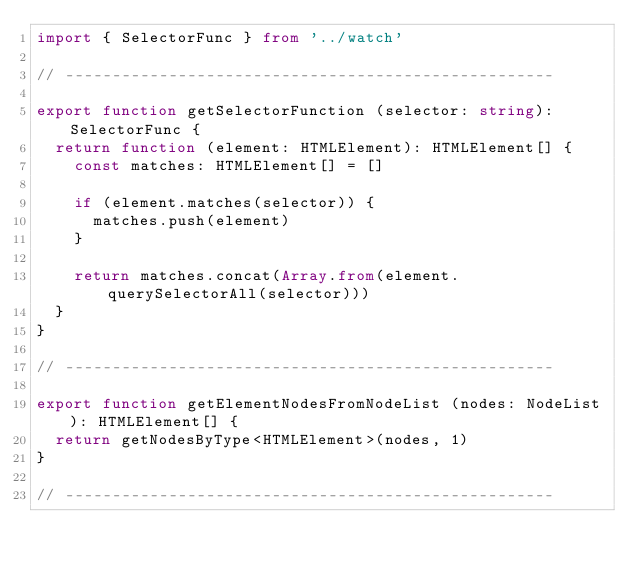<code> <loc_0><loc_0><loc_500><loc_500><_TypeScript_>import { SelectorFunc } from '../watch'

// ----------------------------------------------------

export function getSelectorFunction (selector: string): SelectorFunc {
  return function (element: HTMLElement): HTMLElement[] {
    const matches: HTMLElement[] = []

    if (element.matches(selector)) {
      matches.push(element)
    }

    return matches.concat(Array.from(element.querySelectorAll(selector)))
  }
}

// ----------------------------------------------------

export function getElementNodesFromNodeList (nodes: NodeList): HTMLElement[] {
  return getNodesByType<HTMLElement>(nodes, 1)
}

// ----------------------------------------------------
</code> 